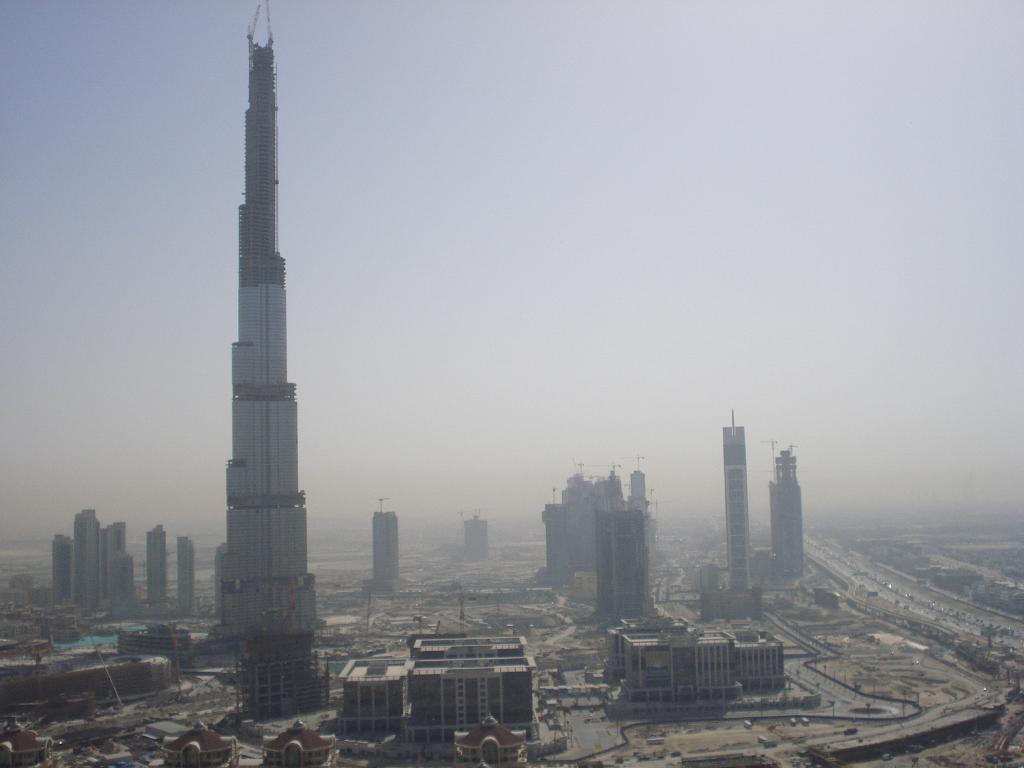In one or two sentences, can you explain what this image depicts? It is the image of a well developed city,there are lot of buildings and huge towers and very wide length roads. 